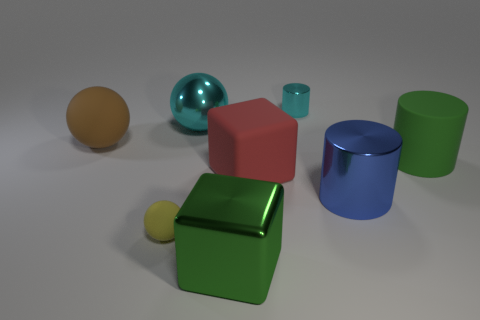Add 1 large metal cubes. How many objects exist? 9 Subtract all cylinders. How many objects are left? 5 Add 5 small things. How many small things are left? 7 Add 5 cyan shiny spheres. How many cyan shiny spheres exist? 6 Subtract 0 blue balls. How many objects are left? 8 Subtract all matte blocks. Subtract all big things. How many objects are left? 1 